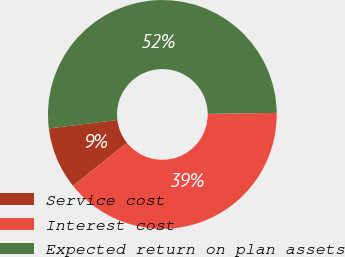Convert chart to OTSL. <chart><loc_0><loc_0><loc_500><loc_500><pie_chart><fcel>Service cost<fcel>Interest cost<fcel>Expected return on plan assets<nl><fcel>8.78%<fcel>39.48%<fcel>51.74%<nl></chart> 